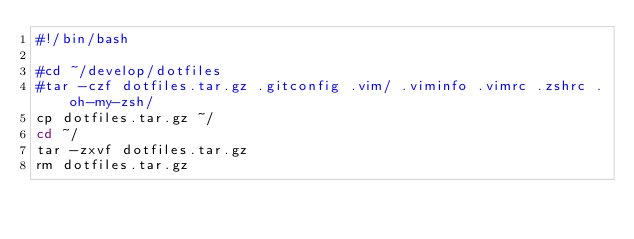<code> <loc_0><loc_0><loc_500><loc_500><_Bash_>#!/bin/bash

#cd ~/develop/dotfiles
#tar -czf dotfiles.tar.gz .gitconfig .vim/ .viminfo .vimrc .zshrc .oh-my-zsh/
cp dotfiles.tar.gz ~/
cd ~/
tar -zxvf dotfiles.tar.gz
rm dotfiles.tar.gz</code> 